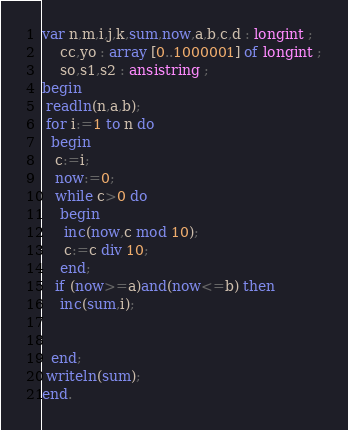Convert code to text. <code><loc_0><loc_0><loc_500><loc_500><_Pascal_>var n,m,i,j,k,sum,now,a,b,c,d : longint ;
    cc,yo : array [0..1000001] of longint ;
    so,s1,s2 : ansistring ;
begin
 readln(n,a,b);
 for i:=1 to n do
  begin
   c:=i;
   now:=0;
   while c>0 do
    begin
     inc(now,c mod 10);
     c:=c div 10;
    end;
   if (now>=a)and(now<=b) then
    inc(sum,i);

 
  end;
 writeln(sum);
end.
</code> 